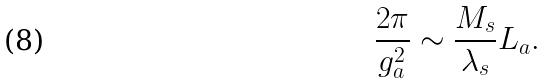Convert formula to latex. <formula><loc_0><loc_0><loc_500><loc_500>\frac { 2 \pi } { g _ { a } ^ { 2 } } \sim \frac { M _ { s } } { \lambda _ { s } } L _ { a } .</formula> 